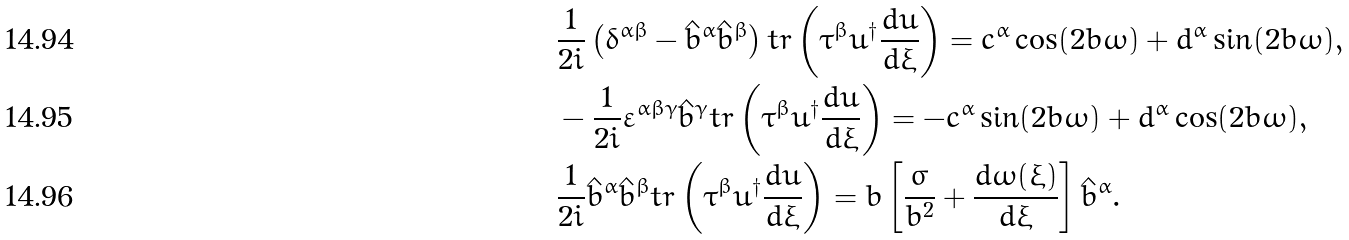Convert formula to latex. <formula><loc_0><loc_0><loc_500><loc_500>& \frac { 1 } { 2 i } \left ( \delta ^ { \alpha \beta } - \hat { b } ^ { \alpha } \hat { b } ^ { \beta } \right ) t r \left ( \tau ^ { \beta } u ^ { \dagger } \frac { d u } { d \xi } \right ) = c ^ { \alpha } \cos ( 2 b \omega ) + d ^ { \alpha } \sin ( 2 b \omega ) , \\ & - \frac { 1 } { 2 i } \varepsilon ^ { \alpha \beta \gamma } \hat { b } ^ { \gamma } t r \left ( \tau ^ { \beta } u ^ { \dagger } \frac { d u } { d \xi } \right ) = - c ^ { \alpha } \sin ( 2 b \omega ) + d ^ { \alpha } \cos ( 2 b \omega ) , \\ & \frac { 1 } { 2 i } \hat { b } ^ { \alpha } \hat { b } ^ { \beta } t r \left ( \tau ^ { \beta } u ^ { \dagger } \frac { d u } { d \xi } \right ) = b \left [ \frac { \sigma } { b ^ { 2 } } + \frac { d \omega ( \xi ) } { d \xi } \right ] \hat { b } ^ { \alpha } .</formula> 